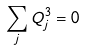<formula> <loc_0><loc_0><loc_500><loc_500>\sum _ { j } Q _ { j } ^ { 3 } = 0</formula> 